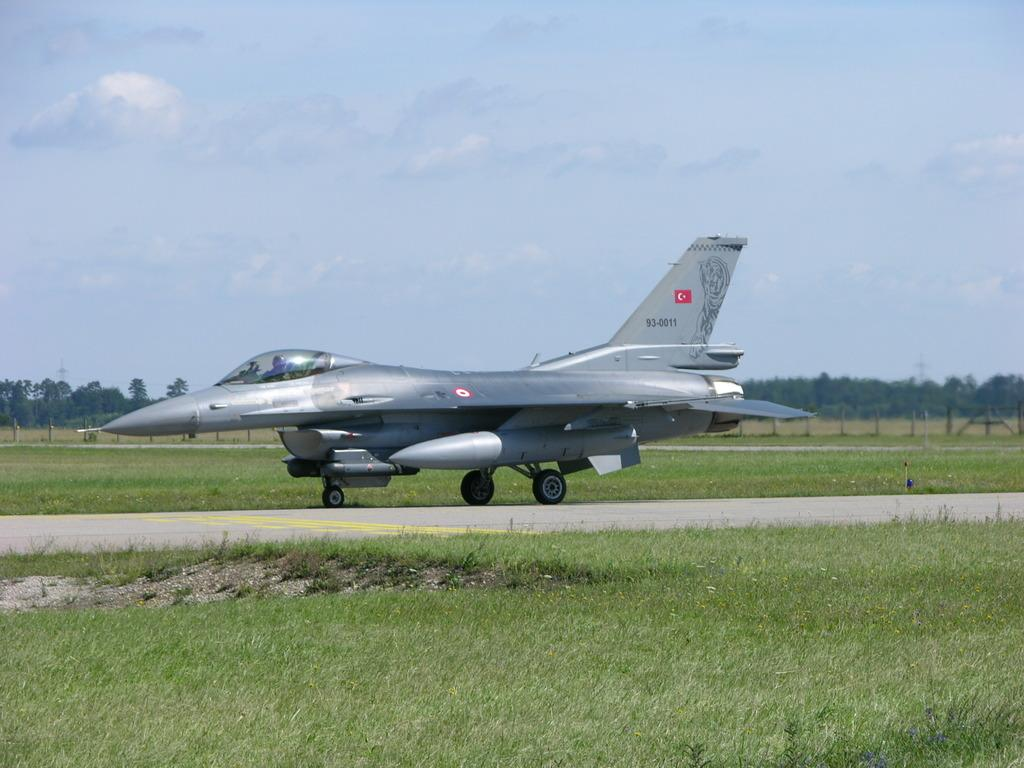What is the main subject in the center of the image? There is an airplane in the center of the image. What type of terrain is visible at the bottom of the image? There is grass at the bottom of the image. What can be seen at the bottom of the image besides grass? There is a walkway at the bottom of the image. What structures are visible in the background of the image? There are poles in the background of the image. What type of vegetation is visible in the background of the image? There are trees in the background of the image. What is visible at the top of the image? The sky is visible at the top of the image. How many ears of corn can be seen in the image? There are no ears of corn present in the image. 